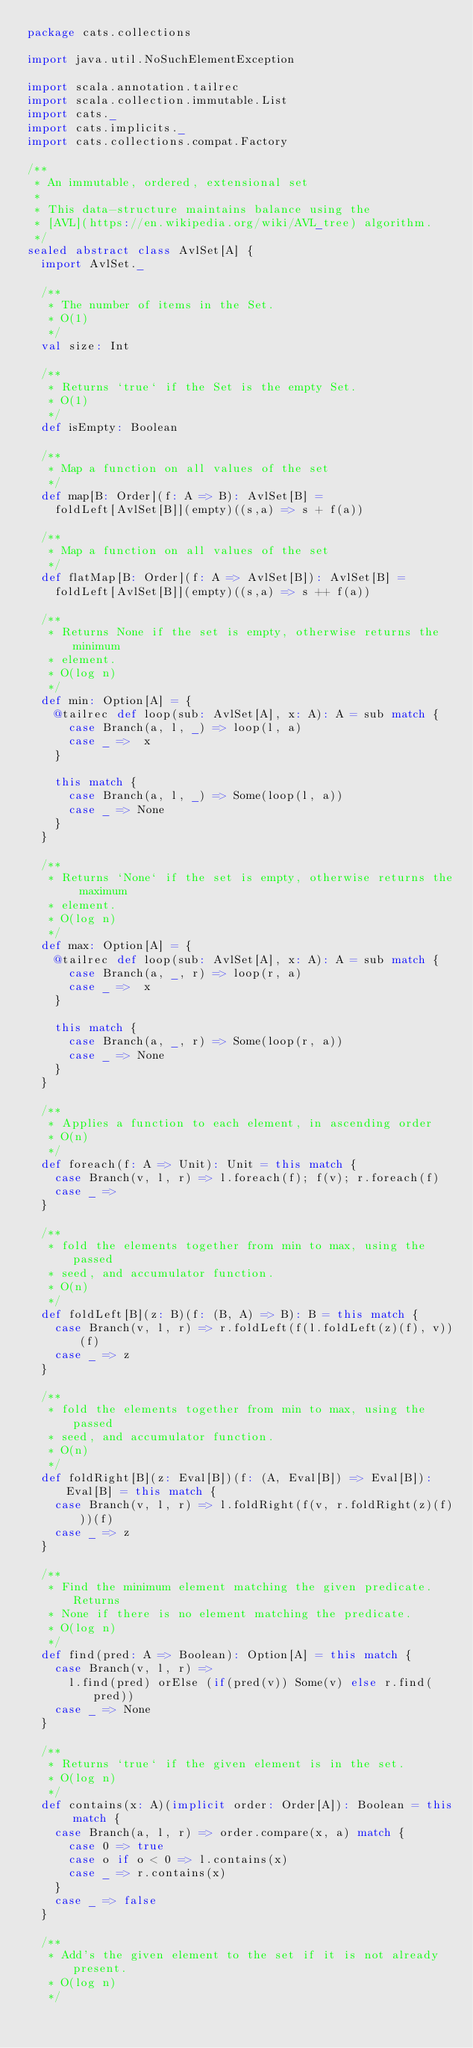Convert code to text. <code><loc_0><loc_0><loc_500><loc_500><_Scala_>package cats.collections

import java.util.NoSuchElementException

import scala.annotation.tailrec
import scala.collection.immutable.List
import cats._
import cats.implicits._
import cats.collections.compat.Factory

/**
 * An immutable, ordered, extensional set
 *
 * This data-structure maintains balance using the
 * [AVL](https://en.wikipedia.org/wiki/AVL_tree) algorithm.
 */
sealed abstract class AvlSet[A] {
  import AvlSet._

  /**
   * The number of items in the Set.
   * O(1)
   */
  val size: Int

  /**
   * Returns `true` if the Set is the empty Set.
   * O(1)
   */
  def isEmpty: Boolean

  /**
   * Map a function on all values of the set
   */
  def map[B: Order](f: A => B): AvlSet[B] =
    foldLeft[AvlSet[B]](empty)((s,a) => s + f(a))

  /**
   * Map a function on all values of the set
   */
  def flatMap[B: Order](f: A => AvlSet[B]): AvlSet[B] =
    foldLeft[AvlSet[B]](empty)((s,a) => s ++ f(a))

  /**
   * Returns None if the set is empty, otherwise returns the minimum
   * element.
   * O(log n)
   */
  def min: Option[A] = {
    @tailrec def loop(sub: AvlSet[A], x: A): A = sub match {
      case Branch(a, l, _) => loop(l, a)
      case _ =>  x
    }

    this match {
      case Branch(a, l, _) => Some(loop(l, a))
      case _ => None
    }
  }

  /**
   * Returns `None` if the set is empty, otherwise returns the maximum
   * element.
   * O(log n)
   */
  def max: Option[A] = {
    @tailrec def loop(sub: AvlSet[A], x: A): A = sub match {
      case Branch(a, _, r) => loop(r, a)
      case _ =>  x
    }

    this match {
      case Branch(a, _, r) => Some(loop(r, a))
      case _ => None
    }
  }

  /**
   * Applies a function to each element, in ascending order
   * O(n)
   */
  def foreach(f: A => Unit): Unit = this match {
    case Branch(v, l, r) => l.foreach(f); f(v); r.foreach(f)
    case _ =>
  }

  /**
   * fold the elements together from min to max, using the passed
   * seed, and accumulator function.
   * O(n)
   */
  def foldLeft[B](z: B)(f: (B, A) => B): B = this match {
    case Branch(v, l, r) => r.foldLeft(f(l.foldLeft(z)(f), v))(f)
    case _ => z
  }

  /**
   * fold the elements together from min to max, using the passed
   * seed, and accumulator function.
   * O(n)
   */
  def foldRight[B](z: Eval[B])(f: (A, Eval[B]) => Eval[B]): Eval[B] = this match {
    case Branch(v, l, r) => l.foldRight(f(v, r.foldRight(z)(f)))(f)
    case _ => z
  }

  /**
   * Find the minimum element matching the given predicate. Returns
   * None if there is no element matching the predicate.
   * O(log n)
   */
  def find(pred: A => Boolean): Option[A] = this match {
    case Branch(v, l, r) =>
      l.find(pred) orElse (if(pred(v)) Some(v) else r.find(pred))
    case _ => None
  }

  /**
   * Returns `true` if the given element is in the set.
   * O(log n)
   */
  def contains(x: A)(implicit order: Order[A]): Boolean = this match {
    case Branch(a, l, r) => order.compare(x, a) match {
      case 0 => true
      case o if o < 0 => l.contains(x)
      case _ => r.contains(x)
    }
    case _ => false
  }

  /**
   * Add's the given element to the set if it is not already present.
   * O(log n)
   */</code> 